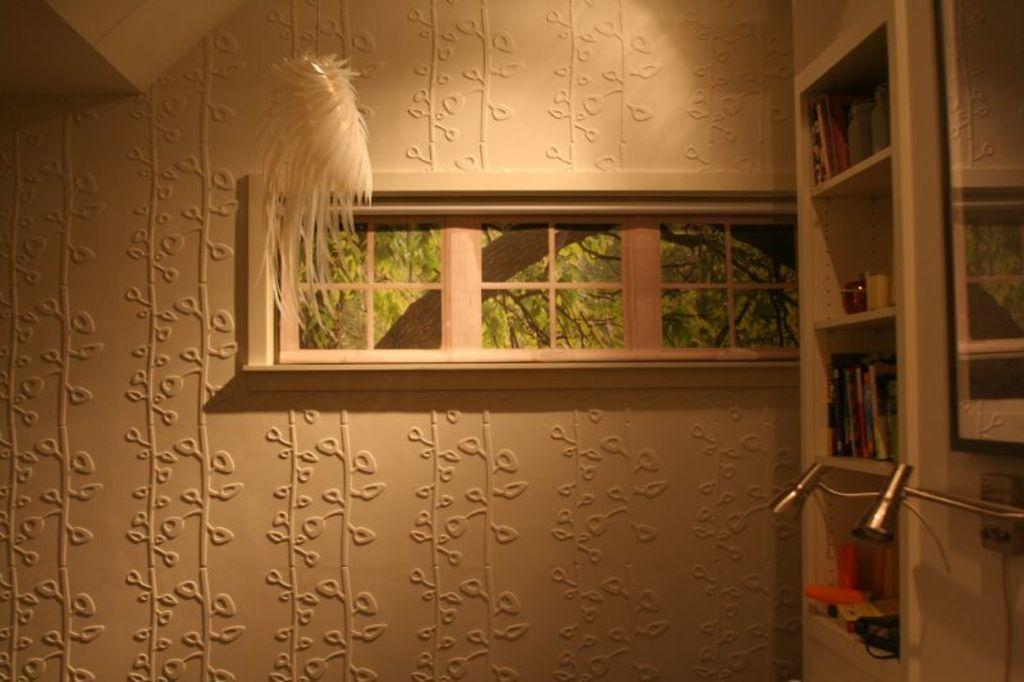What is present on the wall in the image? There is a design on the wall in the image. Can you describe the design on the wall? The design on the wall is not specified in the facts provided. What is located in the middle of the wall? There is a window in the middle of the wall. What can be found on the right side of the wall? There are shelves on the right side of the wall. What items are on the shelves? There are books and playing toys on the shelves. What type of pickle can be seen growing on the shelves in the image? There is no pickle present in the image; the shelves contain books and playing toys. 